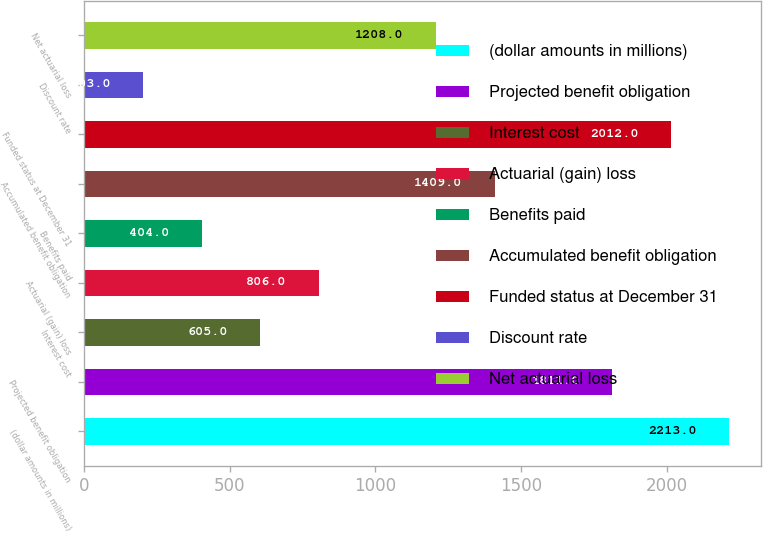Convert chart. <chart><loc_0><loc_0><loc_500><loc_500><bar_chart><fcel>(dollar amounts in millions)<fcel>Projected benefit obligation<fcel>Interest cost<fcel>Actuarial (gain) loss<fcel>Benefits paid<fcel>Accumulated benefit obligation<fcel>Funded status at December 31<fcel>Discount rate<fcel>Net actuarial loss<nl><fcel>2213<fcel>1811<fcel>605<fcel>806<fcel>404<fcel>1409<fcel>2012<fcel>203<fcel>1208<nl></chart> 